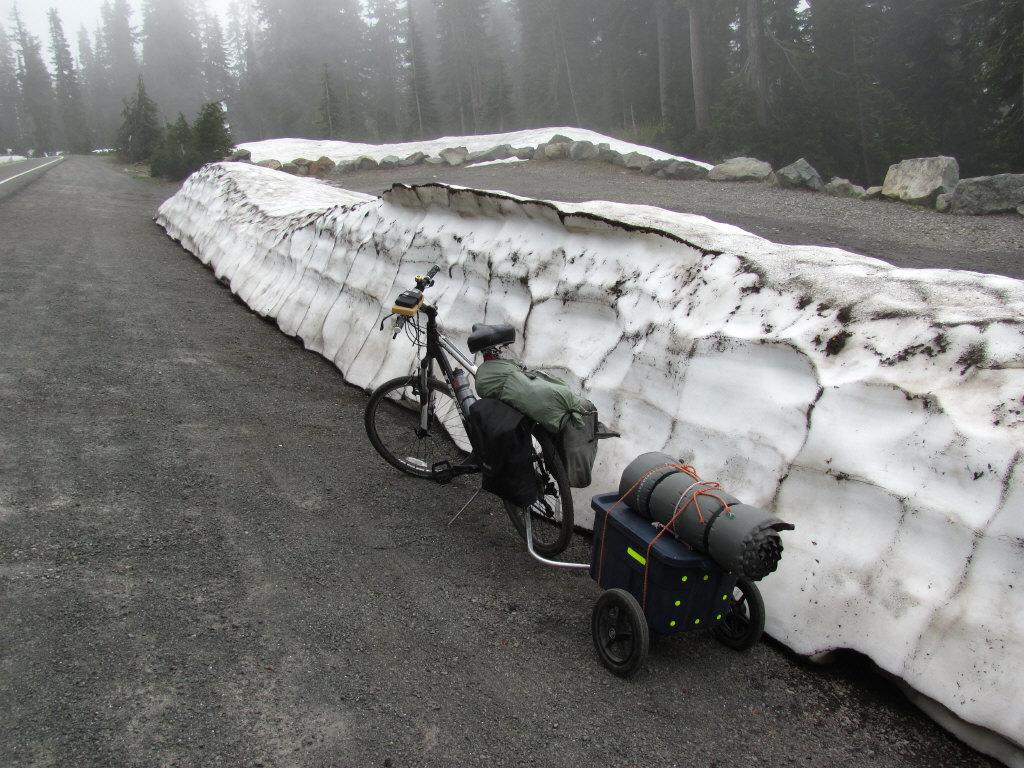What is the main subject in the center of the image? There is a cycle in the center of the image. Where is the cycle located? The cycle is on the road. What can be seen in the background of the image? There is a wall, trees, rocks, and the sky visible in the background. What advice is the cycle giving to the horses in the image? There are no horses present in the image, so the cycle cannot give any advice to them. 